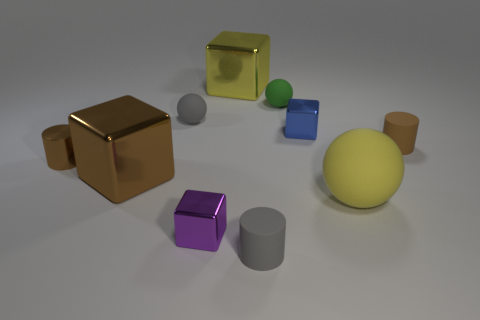Subtract 1 cylinders. How many cylinders are left? 2 Subtract all brown blocks. How many blocks are left? 3 Subtract all brown cylinders. How many cylinders are left? 1 Subtract all blocks. How many objects are left? 6 Subtract all cyan blocks. Subtract all blue cylinders. How many blocks are left? 4 Subtract 1 yellow blocks. How many objects are left? 9 Subtract all metallic cylinders. Subtract all large yellow balls. How many objects are left? 8 Add 9 purple metal blocks. How many purple metal blocks are left? 10 Add 6 blue metal cylinders. How many blue metal cylinders exist? 6 